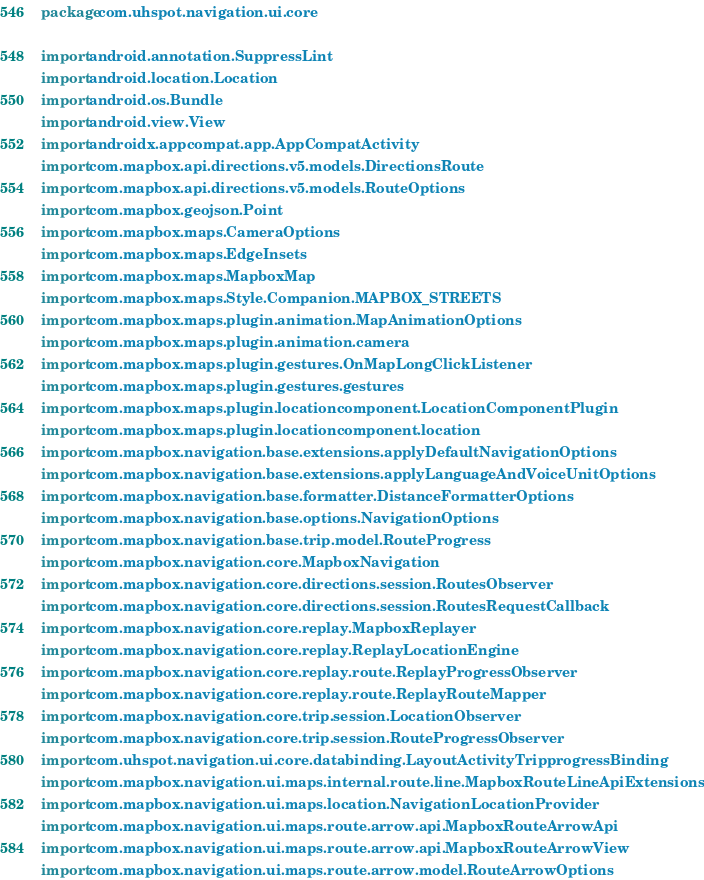<code> <loc_0><loc_0><loc_500><loc_500><_Kotlin_>package com.uhspot.navigation.ui.core

import android.annotation.SuppressLint
import android.location.Location
import android.os.Bundle
import android.view.View
import androidx.appcompat.app.AppCompatActivity
import com.mapbox.api.directions.v5.models.DirectionsRoute
import com.mapbox.api.directions.v5.models.RouteOptions
import com.mapbox.geojson.Point
import com.mapbox.maps.CameraOptions
import com.mapbox.maps.EdgeInsets
import com.mapbox.maps.MapboxMap
import com.mapbox.maps.Style.Companion.MAPBOX_STREETS
import com.mapbox.maps.plugin.animation.MapAnimationOptions
import com.mapbox.maps.plugin.animation.camera
import com.mapbox.maps.plugin.gestures.OnMapLongClickListener
import com.mapbox.maps.plugin.gestures.gestures
import com.mapbox.maps.plugin.locationcomponent.LocationComponentPlugin
import com.mapbox.maps.plugin.locationcomponent.location
import com.mapbox.navigation.base.extensions.applyDefaultNavigationOptions
import com.mapbox.navigation.base.extensions.applyLanguageAndVoiceUnitOptions
import com.mapbox.navigation.base.formatter.DistanceFormatterOptions
import com.mapbox.navigation.base.options.NavigationOptions
import com.mapbox.navigation.base.trip.model.RouteProgress
import com.mapbox.navigation.core.MapboxNavigation
import com.mapbox.navigation.core.directions.session.RoutesObserver
import com.mapbox.navigation.core.directions.session.RoutesRequestCallback
import com.mapbox.navigation.core.replay.MapboxReplayer
import com.mapbox.navigation.core.replay.ReplayLocationEngine
import com.mapbox.navigation.core.replay.route.ReplayProgressObserver
import com.mapbox.navigation.core.replay.route.ReplayRouteMapper
import com.mapbox.navigation.core.trip.session.LocationObserver
import com.mapbox.navigation.core.trip.session.RouteProgressObserver
import com.uhspot.navigation.ui.core.databinding.LayoutActivityTripprogressBinding
import com.mapbox.navigation.ui.maps.internal.route.line.MapboxRouteLineApiExtensions.setRoutes
import com.mapbox.navigation.ui.maps.location.NavigationLocationProvider
import com.mapbox.navigation.ui.maps.route.arrow.api.MapboxRouteArrowApi
import com.mapbox.navigation.ui.maps.route.arrow.api.MapboxRouteArrowView
import com.mapbox.navigation.ui.maps.route.arrow.model.RouteArrowOptions</code> 